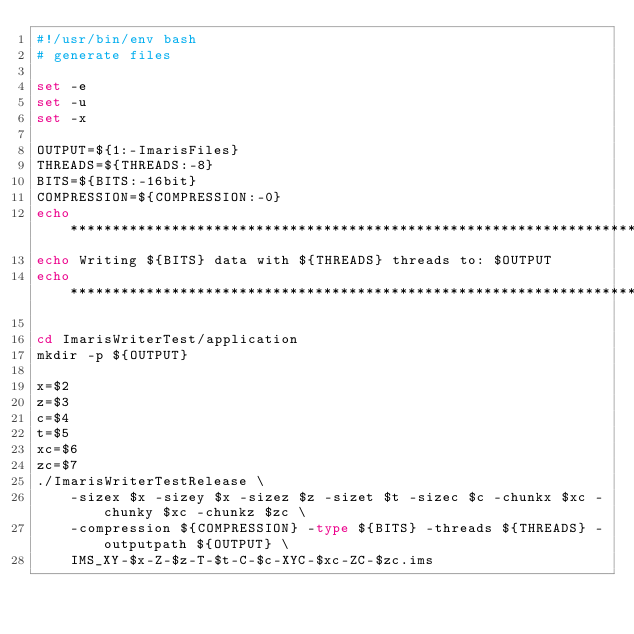<code> <loc_0><loc_0><loc_500><loc_500><_Bash_>#!/usr/bin/env bash
# generate files

set -e
set -u
set -x

OUTPUT=${1:-ImarisFiles}
THREADS=${THREADS:-8}
BITS=${BITS:-16bit}
COMPRESSION=${COMPRESSION:-0}
echo ********************************************************************
echo Writing ${BITS} data with ${THREADS} threads to: $OUTPUT
echo ********************************************************************

cd ImarisWriterTest/application
mkdir -p ${OUTPUT}

x=$2
z=$3
c=$4
t=$5
xc=$6
zc=$7
./ImarisWriterTestRelease \
	-sizex $x -sizey $x -sizez $z -sizet $t -sizec $c -chunkx $xc -chunky $xc -chunkz $zc \
	-compression ${COMPRESSION} -type ${BITS} -threads ${THREADS} -outputpath ${OUTPUT} \
	IMS_XY-$x-Z-$z-T-$t-C-$c-XYC-$xc-ZC-$zc.ims
</code> 